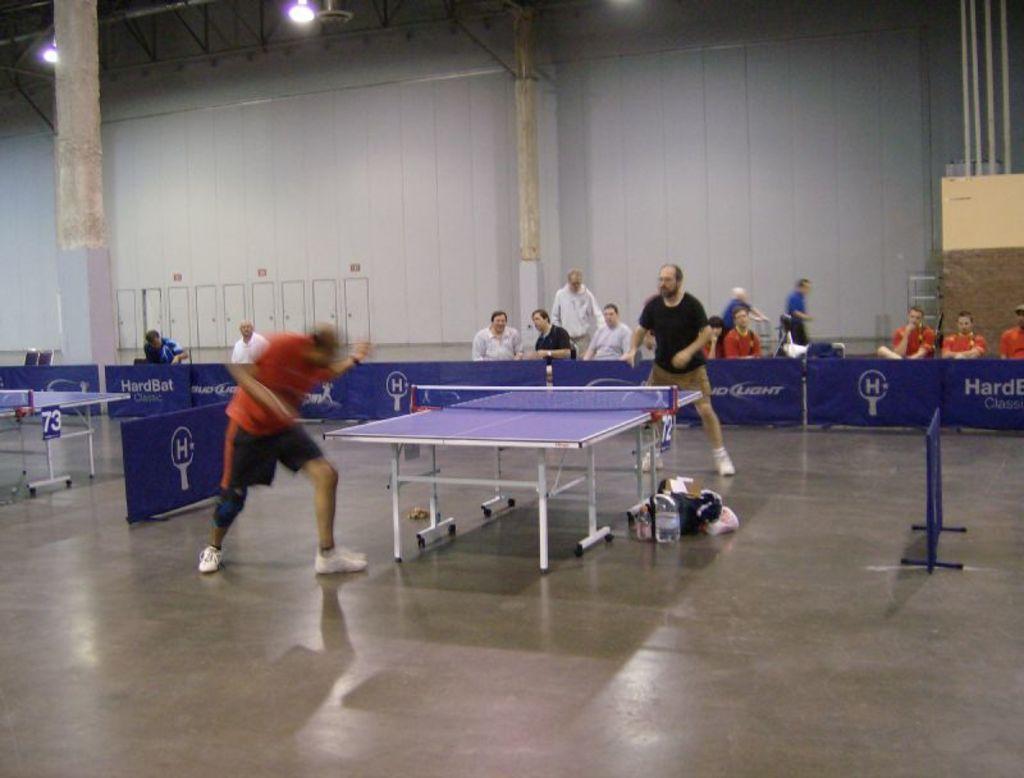Describe this image in one or two sentences. In this image we can see two men standing beside the table tennis board holding the rackets. We can also see some objects, a table tennis board and a stand on the floor. On the backside we can see a group of people beside the fence, some pillars, doors, wall, some poles and a roof with some ceiling lights. 